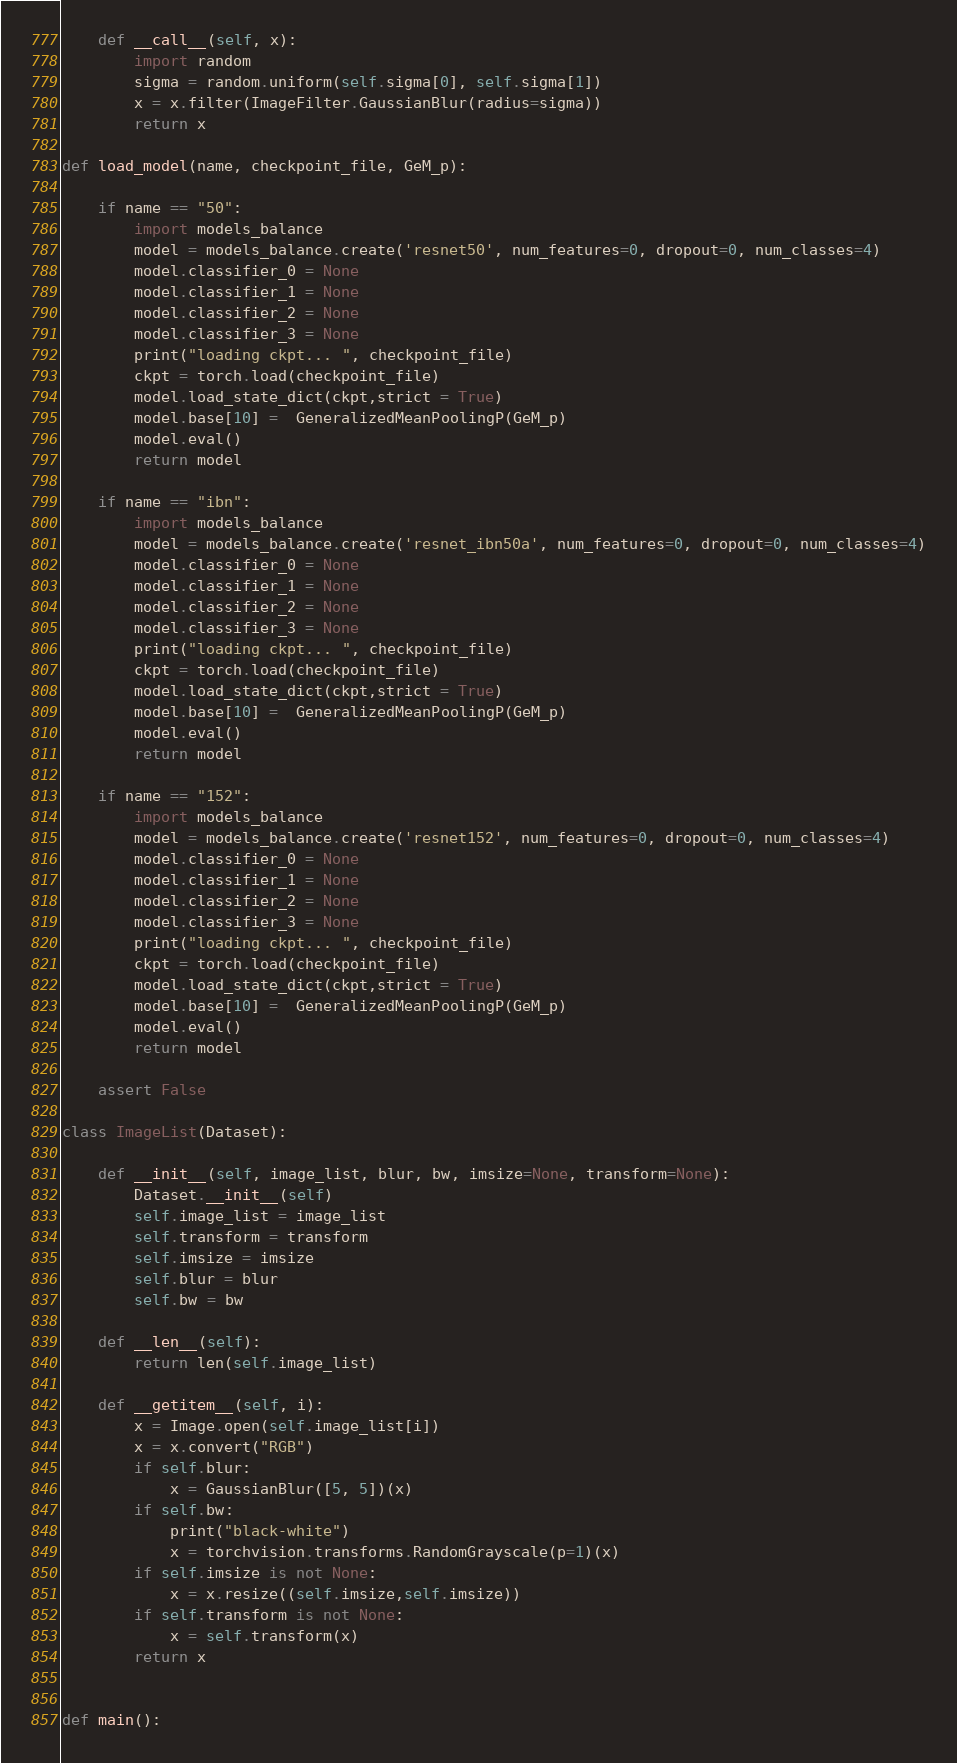Convert code to text. <code><loc_0><loc_0><loc_500><loc_500><_Python_>
    def __call__(self, x):
        import random
        sigma = random.uniform(self.sigma[0], self.sigma[1])
        x = x.filter(ImageFilter.GaussianBlur(radius=sigma))
        return x

def load_model(name, checkpoint_file, GeM_p):
    
    if name == "50":
        import models_balance
        model = models_balance.create('resnet50', num_features=0, dropout=0, num_classes=4)
        model.classifier_0 = None
        model.classifier_1 = None
        model.classifier_2 = None
        model.classifier_3 = None
        print("loading ckpt... ", checkpoint_file)
        ckpt = torch.load(checkpoint_file)
        model.load_state_dict(ckpt,strict = True)
        model.base[10] =  GeneralizedMeanPoolingP(GeM_p)
        model.eval()
        return model
    
    if name == "ibn":
        import models_balance
        model = models_balance.create('resnet_ibn50a', num_features=0, dropout=0, num_classes=4)
        model.classifier_0 = None
        model.classifier_1 = None
        model.classifier_2 = None
        model.classifier_3 = None
        print("loading ckpt... ", checkpoint_file)
        ckpt = torch.load(checkpoint_file)
        model.load_state_dict(ckpt,strict = True)
        model.base[10] =  GeneralizedMeanPoolingP(GeM_p)
        model.eval()
        return model
    
    if name == "152":
        import models_balance
        model = models_balance.create('resnet152', num_features=0, dropout=0, num_classes=4)
        model.classifier_0 = None
        model.classifier_1 = None
        model.classifier_2 = None
        model.classifier_3 = None
        print("loading ckpt... ", checkpoint_file)
        ckpt = torch.load(checkpoint_file)
        model.load_state_dict(ckpt,strict = True)
        model.base[10] =  GeneralizedMeanPoolingP(GeM_p)
        model.eval()
        return model
    
    assert False

class ImageList(Dataset):

    def __init__(self, image_list, blur, bw, imsize=None, transform=None):
        Dataset.__init__(self)
        self.image_list = image_list
        self.transform = transform
        self.imsize = imsize
        self.blur = blur
        self.bw = bw

    def __len__(self):
        return len(self.image_list)

    def __getitem__(self, i):
        x = Image.open(self.image_list[i])
        x = x.convert("RGB")
        if self.blur:
            x = GaussianBlur([5, 5])(x)
        if self.bw:
            print("black-white")
            x = torchvision.transforms.RandomGrayscale(p=1)(x)
        if self.imsize is not None:
            x = x.resize((self.imsize,self.imsize))
        if self.transform is not None:
            x = self.transform(x)
        return x


def main():
</code> 